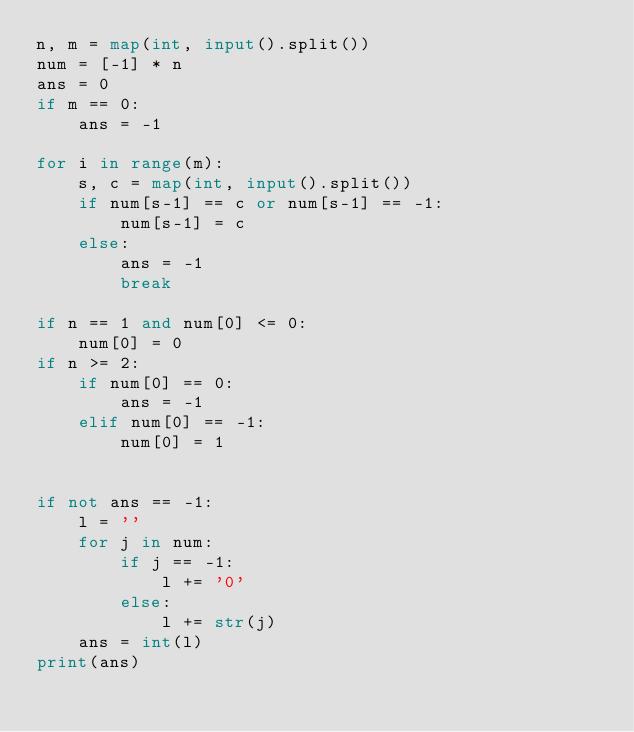Convert code to text. <code><loc_0><loc_0><loc_500><loc_500><_Python_>n, m = map(int, input().split())
num = [-1] * n
ans = 0
if m == 0:
    ans = -1

for i in range(m):
    s, c = map(int, input().split())
    if num[s-1] == c or num[s-1] == -1:
        num[s-1] = c
    else:
        ans = -1
        break
    
if n == 1 and num[0] <= 0:
    num[0] = 0
if n >= 2:
    if num[0] == 0:
        ans = -1
    elif num[0] == -1:
        num[0] = 1

        
if not ans == -1:
    l = ''
    for j in num:
        if j == -1:
            l += '0'
        else:
            l += str(j)
    ans = int(l)        
print(ans)
    </code> 